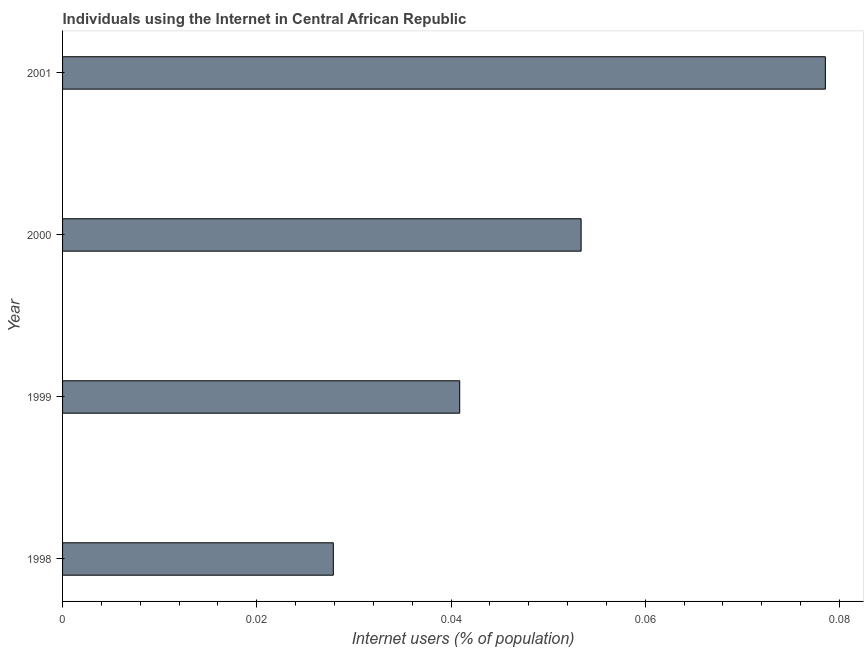Does the graph contain any zero values?
Give a very brief answer. No. What is the title of the graph?
Offer a terse response. Individuals using the Internet in Central African Republic. What is the label or title of the X-axis?
Offer a terse response. Internet users (% of population). What is the label or title of the Y-axis?
Offer a very short reply. Year. What is the number of internet users in 1999?
Offer a terse response. 0.04. Across all years, what is the maximum number of internet users?
Offer a terse response. 0.08. Across all years, what is the minimum number of internet users?
Your answer should be compact. 0.03. In which year was the number of internet users maximum?
Your answer should be very brief. 2001. What is the sum of the number of internet users?
Your answer should be compact. 0.2. What is the difference between the number of internet users in 1998 and 2000?
Offer a terse response. -0.03. What is the average number of internet users per year?
Offer a terse response. 0.05. What is the median number of internet users?
Make the answer very short. 0.05. What is the ratio of the number of internet users in 1998 to that in 2000?
Keep it short and to the point. 0.52. Is the difference between the number of internet users in 1999 and 2001 greater than the difference between any two years?
Make the answer very short. No. What is the difference between the highest and the second highest number of internet users?
Offer a very short reply. 0.03. Is the sum of the number of internet users in 1998 and 2001 greater than the maximum number of internet users across all years?
Your response must be concise. Yes. What is the difference between the highest and the lowest number of internet users?
Keep it short and to the point. 0.05. In how many years, is the number of internet users greater than the average number of internet users taken over all years?
Ensure brevity in your answer.  2. Are all the bars in the graph horizontal?
Offer a very short reply. Yes. How many years are there in the graph?
Provide a succinct answer. 4. What is the Internet users (% of population) in 1998?
Provide a succinct answer. 0.03. What is the Internet users (% of population) of 1999?
Keep it short and to the point. 0.04. What is the Internet users (% of population) of 2000?
Provide a short and direct response. 0.05. What is the Internet users (% of population) of 2001?
Provide a succinct answer. 0.08. What is the difference between the Internet users (% of population) in 1998 and 1999?
Your response must be concise. -0.01. What is the difference between the Internet users (% of population) in 1998 and 2000?
Make the answer very short. -0.03. What is the difference between the Internet users (% of population) in 1998 and 2001?
Provide a succinct answer. -0.05. What is the difference between the Internet users (% of population) in 1999 and 2000?
Offer a terse response. -0.01. What is the difference between the Internet users (% of population) in 1999 and 2001?
Give a very brief answer. -0.04. What is the difference between the Internet users (% of population) in 2000 and 2001?
Provide a short and direct response. -0.03. What is the ratio of the Internet users (% of population) in 1998 to that in 1999?
Make the answer very short. 0.68. What is the ratio of the Internet users (% of population) in 1998 to that in 2000?
Your answer should be very brief. 0.52. What is the ratio of the Internet users (% of population) in 1998 to that in 2001?
Offer a very short reply. 0.35. What is the ratio of the Internet users (% of population) in 1999 to that in 2000?
Provide a short and direct response. 0.77. What is the ratio of the Internet users (% of population) in 1999 to that in 2001?
Give a very brief answer. 0.52. What is the ratio of the Internet users (% of population) in 2000 to that in 2001?
Provide a short and direct response. 0.68. 